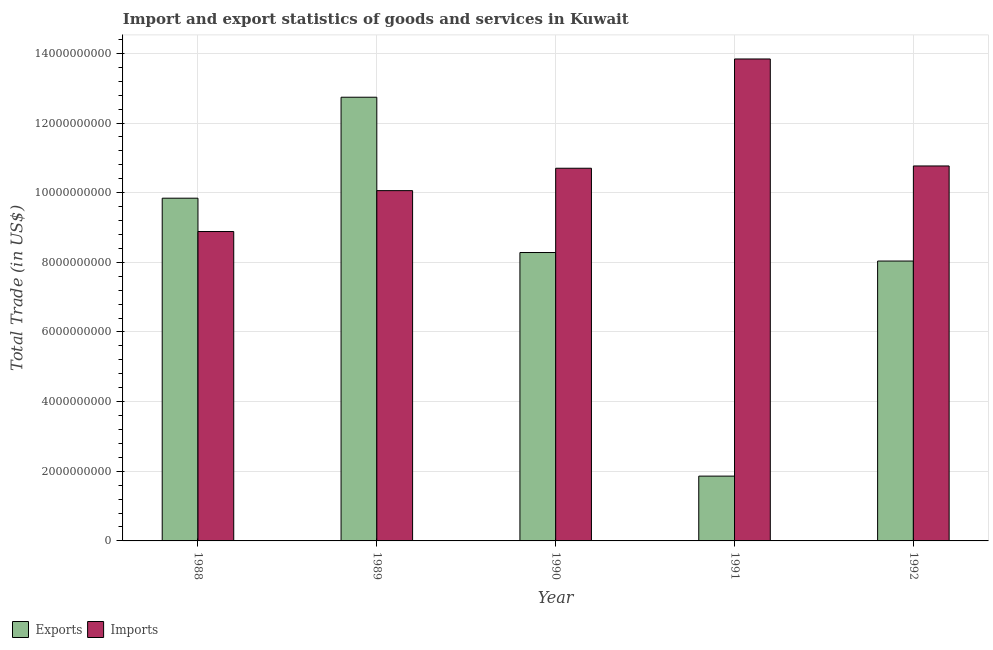How many different coloured bars are there?
Give a very brief answer. 2. How many bars are there on the 5th tick from the left?
Make the answer very short. 2. How many bars are there on the 3rd tick from the right?
Offer a terse response. 2. In how many cases, is the number of bars for a given year not equal to the number of legend labels?
Provide a short and direct response. 0. What is the imports of goods and services in 1992?
Give a very brief answer. 1.08e+1. Across all years, what is the maximum export of goods and services?
Your answer should be very brief. 1.27e+1. Across all years, what is the minimum export of goods and services?
Your answer should be compact. 1.86e+09. What is the total imports of goods and services in the graph?
Give a very brief answer. 5.43e+1. What is the difference between the imports of goods and services in 1989 and that in 1991?
Ensure brevity in your answer.  -3.78e+09. What is the difference between the imports of goods and services in 1990 and the export of goods and services in 1989?
Provide a short and direct response. 6.43e+08. What is the average imports of goods and services per year?
Give a very brief answer. 1.09e+1. What is the ratio of the export of goods and services in 1988 to that in 1990?
Give a very brief answer. 1.19. Is the imports of goods and services in 1988 less than that in 1990?
Your answer should be compact. Yes. What is the difference between the highest and the second highest export of goods and services?
Provide a short and direct response. 2.90e+09. What is the difference between the highest and the lowest export of goods and services?
Offer a very short reply. 1.09e+1. Is the sum of the export of goods and services in 1990 and 1991 greater than the maximum imports of goods and services across all years?
Give a very brief answer. No. What does the 2nd bar from the left in 1991 represents?
Provide a short and direct response. Imports. What does the 1st bar from the right in 1988 represents?
Make the answer very short. Imports. How many bars are there?
Your answer should be compact. 10. Are all the bars in the graph horizontal?
Your response must be concise. No. How many years are there in the graph?
Offer a terse response. 5. Are the values on the major ticks of Y-axis written in scientific E-notation?
Provide a short and direct response. No. Does the graph contain any zero values?
Your answer should be very brief. No. Does the graph contain grids?
Provide a short and direct response. Yes. How many legend labels are there?
Give a very brief answer. 2. What is the title of the graph?
Offer a terse response. Import and export statistics of goods and services in Kuwait. Does "Time to export" appear as one of the legend labels in the graph?
Your answer should be compact. No. What is the label or title of the Y-axis?
Make the answer very short. Total Trade (in US$). What is the Total Trade (in US$) in Exports in 1988?
Offer a terse response. 9.84e+09. What is the Total Trade (in US$) in Imports in 1988?
Keep it short and to the point. 8.88e+09. What is the Total Trade (in US$) in Exports in 1989?
Provide a short and direct response. 1.27e+1. What is the Total Trade (in US$) in Imports in 1989?
Your answer should be compact. 1.01e+1. What is the Total Trade (in US$) in Exports in 1990?
Your answer should be very brief. 8.28e+09. What is the Total Trade (in US$) in Imports in 1990?
Offer a terse response. 1.07e+1. What is the Total Trade (in US$) of Exports in 1991?
Keep it short and to the point. 1.86e+09. What is the Total Trade (in US$) in Imports in 1991?
Provide a short and direct response. 1.38e+1. What is the Total Trade (in US$) of Exports in 1992?
Make the answer very short. 8.04e+09. What is the Total Trade (in US$) of Imports in 1992?
Your answer should be very brief. 1.08e+1. Across all years, what is the maximum Total Trade (in US$) of Exports?
Make the answer very short. 1.27e+1. Across all years, what is the maximum Total Trade (in US$) in Imports?
Your answer should be very brief. 1.38e+1. Across all years, what is the minimum Total Trade (in US$) in Exports?
Offer a terse response. 1.86e+09. Across all years, what is the minimum Total Trade (in US$) in Imports?
Offer a terse response. 8.88e+09. What is the total Total Trade (in US$) of Exports in the graph?
Make the answer very short. 4.08e+1. What is the total Total Trade (in US$) of Imports in the graph?
Your response must be concise. 5.43e+1. What is the difference between the Total Trade (in US$) in Exports in 1988 and that in 1989?
Provide a short and direct response. -2.90e+09. What is the difference between the Total Trade (in US$) in Imports in 1988 and that in 1989?
Provide a short and direct response. -1.17e+09. What is the difference between the Total Trade (in US$) in Exports in 1988 and that in 1990?
Your response must be concise. 1.56e+09. What is the difference between the Total Trade (in US$) of Imports in 1988 and that in 1990?
Provide a succinct answer. -1.82e+09. What is the difference between the Total Trade (in US$) of Exports in 1988 and that in 1991?
Provide a short and direct response. 7.98e+09. What is the difference between the Total Trade (in US$) of Imports in 1988 and that in 1991?
Provide a succinct answer. -4.95e+09. What is the difference between the Total Trade (in US$) of Exports in 1988 and that in 1992?
Ensure brevity in your answer.  1.80e+09. What is the difference between the Total Trade (in US$) of Imports in 1988 and that in 1992?
Your response must be concise. -1.88e+09. What is the difference between the Total Trade (in US$) of Exports in 1989 and that in 1990?
Keep it short and to the point. 4.46e+09. What is the difference between the Total Trade (in US$) in Imports in 1989 and that in 1990?
Your answer should be compact. -6.43e+08. What is the difference between the Total Trade (in US$) in Exports in 1989 and that in 1991?
Provide a succinct answer. 1.09e+1. What is the difference between the Total Trade (in US$) in Imports in 1989 and that in 1991?
Provide a short and direct response. -3.78e+09. What is the difference between the Total Trade (in US$) of Exports in 1989 and that in 1992?
Your answer should be compact. 4.70e+09. What is the difference between the Total Trade (in US$) in Imports in 1989 and that in 1992?
Your answer should be very brief. -7.08e+08. What is the difference between the Total Trade (in US$) in Exports in 1990 and that in 1991?
Your answer should be compact. 6.42e+09. What is the difference between the Total Trade (in US$) in Imports in 1990 and that in 1991?
Provide a succinct answer. -3.14e+09. What is the difference between the Total Trade (in US$) of Exports in 1990 and that in 1992?
Your response must be concise. 2.44e+08. What is the difference between the Total Trade (in US$) of Imports in 1990 and that in 1992?
Your answer should be compact. -6.55e+07. What is the difference between the Total Trade (in US$) of Exports in 1991 and that in 1992?
Ensure brevity in your answer.  -6.18e+09. What is the difference between the Total Trade (in US$) in Imports in 1991 and that in 1992?
Your response must be concise. 3.07e+09. What is the difference between the Total Trade (in US$) of Exports in 1988 and the Total Trade (in US$) of Imports in 1989?
Offer a terse response. -2.17e+08. What is the difference between the Total Trade (in US$) of Exports in 1988 and the Total Trade (in US$) of Imports in 1990?
Ensure brevity in your answer.  -8.60e+08. What is the difference between the Total Trade (in US$) of Exports in 1988 and the Total Trade (in US$) of Imports in 1991?
Keep it short and to the point. -4.00e+09. What is the difference between the Total Trade (in US$) of Exports in 1988 and the Total Trade (in US$) of Imports in 1992?
Keep it short and to the point. -9.26e+08. What is the difference between the Total Trade (in US$) in Exports in 1989 and the Total Trade (in US$) in Imports in 1990?
Your answer should be very brief. 2.04e+09. What is the difference between the Total Trade (in US$) in Exports in 1989 and the Total Trade (in US$) in Imports in 1991?
Give a very brief answer. -1.10e+09. What is the difference between the Total Trade (in US$) in Exports in 1989 and the Total Trade (in US$) in Imports in 1992?
Keep it short and to the point. 1.97e+09. What is the difference between the Total Trade (in US$) in Exports in 1990 and the Total Trade (in US$) in Imports in 1991?
Ensure brevity in your answer.  -5.56e+09. What is the difference between the Total Trade (in US$) of Exports in 1990 and the Total Trade (in US$) of Imports in 1992?
Give a very brief answer. -2.49e+09. What is the difference between the Total Trade (in US$) of Exports in 1991 and the Total Trade (in US$) of Imports in 1992?
Offer a terse response. -8.91e+09. What is the average Total Trade (in US$) in Exports per year?
Offer a very short reply. 8.15e+09. What is the average Total Trade (in US$) in Imports per year?
Offer a very short reply. 1.09e+1. In the year 1988, what is the difference between the Total Trade (in US$) of Exports and Total Trade (in US$) of Imports?
Ensure brevity in your answer.  9.57e+08. In the year 1989, what is the difference between the Total Trade (in US$) in Exports and Total Trade (in US$) in Imports?
Keep it short and to the point. 2.68e+09. In the year 1990, what is the difference between the Total Trade (in US$) of Exports and Total Trade (in US$) of Imports?
Your answer should be very brief. -2.42e+09. In the year 1991, what is the difference between the Total Trade (in US$) in Exports and Total Trade (in US$) in Imports?
Provide a succinct answer. -1.20e+1. In the year 1992, what is the difference between the Total Trade (in US$) in Exports and Total Trade (in US$) in Imports?
Give a very brief answer. -2.73e+09. What is the ratio of the Total Trade (in US$) of Exports in 1988 to that in 1989?
Provide a succinct answer. 0.77. What is the ratio of the Total Trade (in US$) in Imports in 1988 to that in 1989?
Your response must be concise. 0.88. What is the ratio of the Total Trade (in US$) of Exports in 1988 to that in 1990?
Keep it short and to the point. 1.19. What is the ratio of the Total Trade (in US$) in Imports in 1988 to that in 1990?
Keep it short and to the point. 0.83. What is the ratio of the Total Trade (in US$) in Exports in 1988 to that in 1991?
Give a very brief answer. 5.29. What is the ratio of the Total Trade (in US$) of Imports in 1988 to that in 1991?
Ensure brevity in your answer.  0.64. What is the ratio of the Total Trade (in US$) of Exports in 1988 to that in 1992?
Ensure brevity in your answer.  1.22. What is the ratio of the Total Trade (in US$) in Imports in 1988 to that in 1992?
Provide a short and direct response. 0.83. What is the ratio of the Total Trade (in US$) in Exports in 1989 to that in 1990?
Your response must be concise. 1.54. What is the ratio of the Total Trade (in US$) of Imports in 1989 to that in 1990?
Give a very brief answer. 0.94. What is the ratio of the Total Trade (in US$) in Exports in 1989 to that in 1991?
Offer a terse response. 6.85. What is the ratio of the Total Trade (in US$) in Imports in 1989 to that in 1991?
Provide a short and direct response. 0.73. What is the ratio of the Total Trade (in US$) of Exports in 1989 to that in 1992?
Provide a succinct answer. 1.59. What is the ratio of the Total Trade (in US$) in Imports in 1989 to that in 1992?
Offer a terse response. 0.93. What is the ratio of the Total Trade (in US$) of Exports in 1990 to that in 1991?
Your response must be concise. 4.45. What is the ratio of the Total Trade (in US$) of Imports in 1990 to that in 1991?
Make the answer very short. 0.77. What is the ratio of the Total Trade (in US$) of Exports in 1990 to that in 1992?
Your answer should be very brief. 1.03. What is the ratio of the Total Trade (in US$) in Imports in 1990 to that in 1992?
Ensure brevity in your answer.  0.99. What is the ratio of the Total Trade (in US$) in Exports in 1991 to that in 1992?
Your answer should be compact. 0.23. What is the ratio of the Total Trade (in US$) of Imports in 1991 to that in 1992?
Your answer should be compact. 1.29. What is the difference between the highest and the second highest Total Trade (in US$) of Exports?
Provide a succinct answer. 2.90e+09. What is the difference between the highest and the second highest Total Trade (in US$) of Imports?
Ensure brevity in your answer.  3.07e+09. What is the difference between the highest and the lowest Total Trade (in US$) in Exports?
Your answer should be very brief. 1.09e+1. What is the difference between the highest and the lowest Total Trade (in US$) of Imports?
Your answer should be very brief. 4.95e+09. 